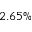<formula> <loc_0><loc_0><loc_500><loc_500>2 . 6 5 \%</formula> 